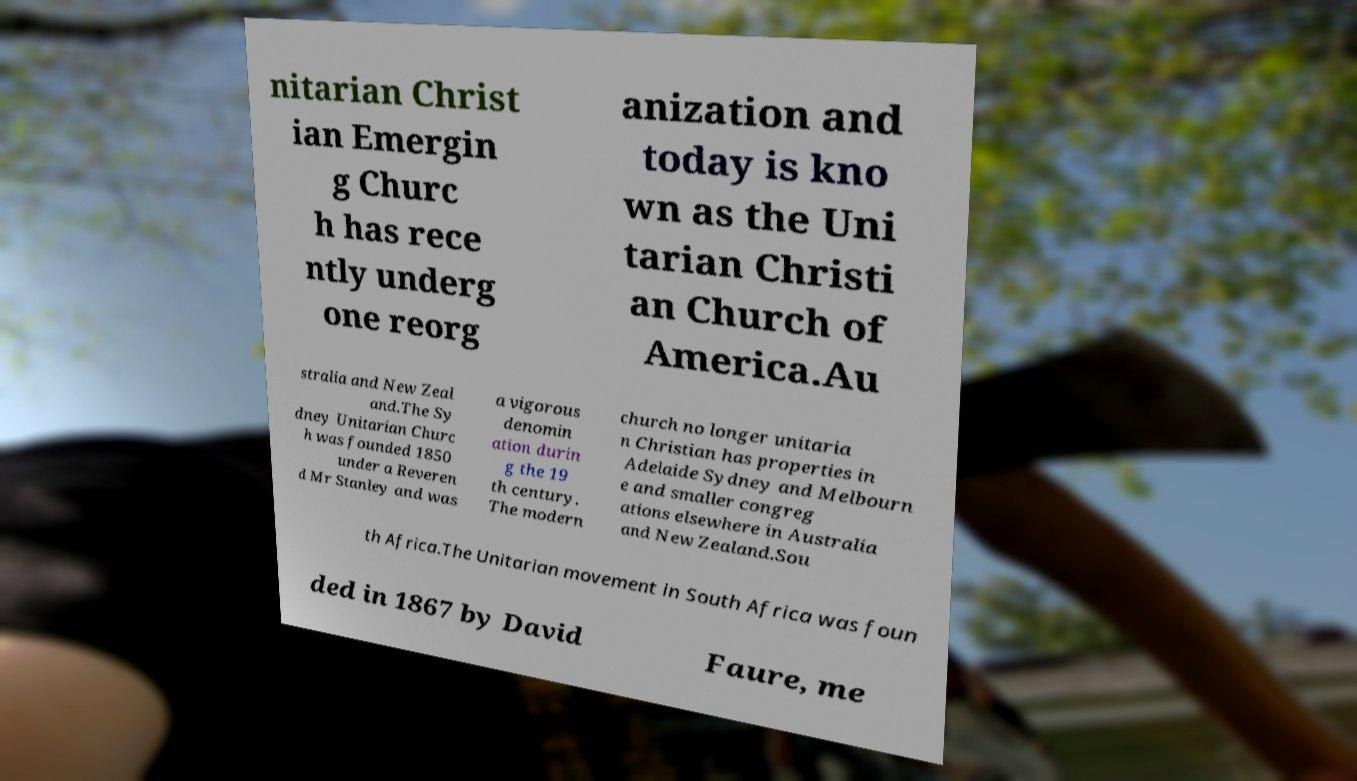Please identify and transcribe the text found in this image. nitarian Christ ian Emergin g Churc h has rece ntly underg one reorg anization and today is kno wn as the Uni tarian Christi an Church of America.Au stralia and New Zeal and.The Sy dney Unitarian Churc h was founded 1850 under a Reveren d Mr Stanley and was a vigorous denomin ation durin g the 19 th century. The modern church no longer unitaria n Christian has properties in Adelaide Sydney and Melbourn e and smaller congreg ations elsewhere in Australia and New Zealand.Sou th Africa.The Unitarian movement in South Africa was foun ded in 1867 by David Faure, me 